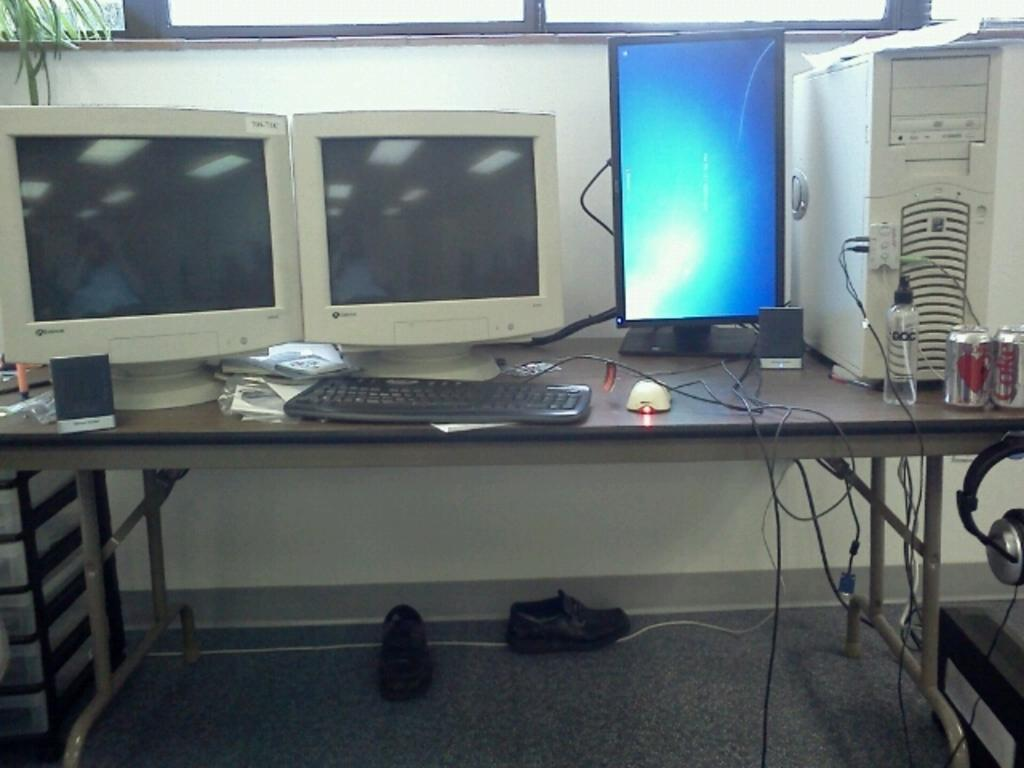What type of furniture is present in the image? There is a table in the image. Where is the table located? The table is on the floor. What electronic devices are on the table? There are monitors, a keyboard, a mouse, and a headphone on the table. Are there any other objects on the table? Yes, there are some objects on the table. What can be seen on the floor besides the table? There are shoes on the floor. What type of dirt can be seen on the floor in the image? There is no dirt visible on the floor in the image; it appears to be clean. 